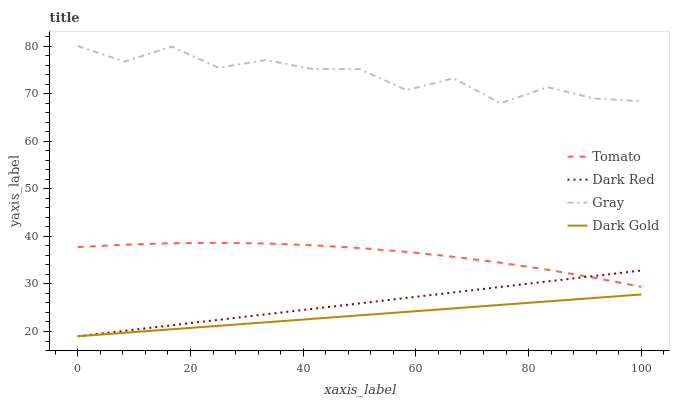Does Dark Gold have the minimum area under the curve?
Answer yes or no. Yes. Does Gray have the maximum area under the curve?
Answer yes or no. Yes. Does Dark Red have the minimum area under the curve?
Answer yes or no. No. Does Dark Red have the maximum area under the curve?
Answer yes or no. No. Is Dark Red the smoothest?
Answer yes or no. Yes. Is Gray the roughest?
Answer yes or no. Yes. Is Dark Gold the smoothest?
Answer yes or no. No. Is Dark Gold the roughest?
Answer yes or no. No. Does Dark Red have the lowest value?
Answer yes or no. Yes. Does Gray have the lowest value?
Answer yes or no. No. Does Gray have the highest value?
Answer yes or no. Yes. Does Dark Red have the highest value?
Answer yes or no. No. Is Dark Gold less than Tomato?
Answer yes or no. Yes. Is Gray greater than Dark Gold?
Answer yes or no. Yes. Does Dark Red intersect Dark Gold?
Answer yes or no. Yes. Is Dark Red less than Dark Gold?
Answer yes or no. No. Is Dark Red greater than Dark Gold?
Answer yes or no. No. Does Dark Gold intersect Tomato?
Answer yes or no. No. 